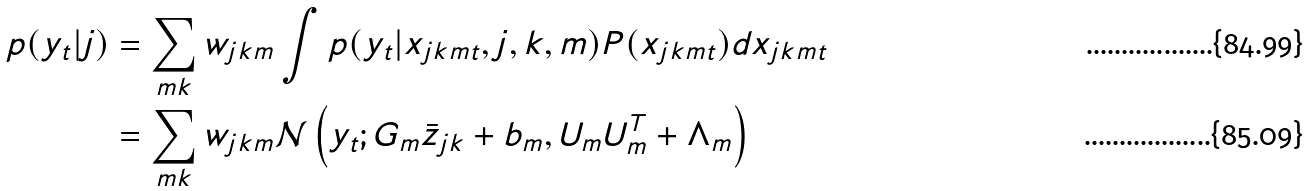Convert formula to latex. <formula><loc_0><loc_0><loc_500><loc_500>p ( y _ { t } | j ) & = \sum _ { m k } w _ { j k m } \int p ( y _ { t } | x _ { j k m t } , j , k , m ) P ( x _ { j k m t } ) d x _ { j k m t } \\ & = \sum _ { m k } w _ { j k m } \mathcal { N } \left ( y _ { t } ; G _ { m } \bar { z } _ { j k } + b _ { m } , U _ { m } U _ { m } ^ { T } + \Lambda _ { m } \right )</formula> 